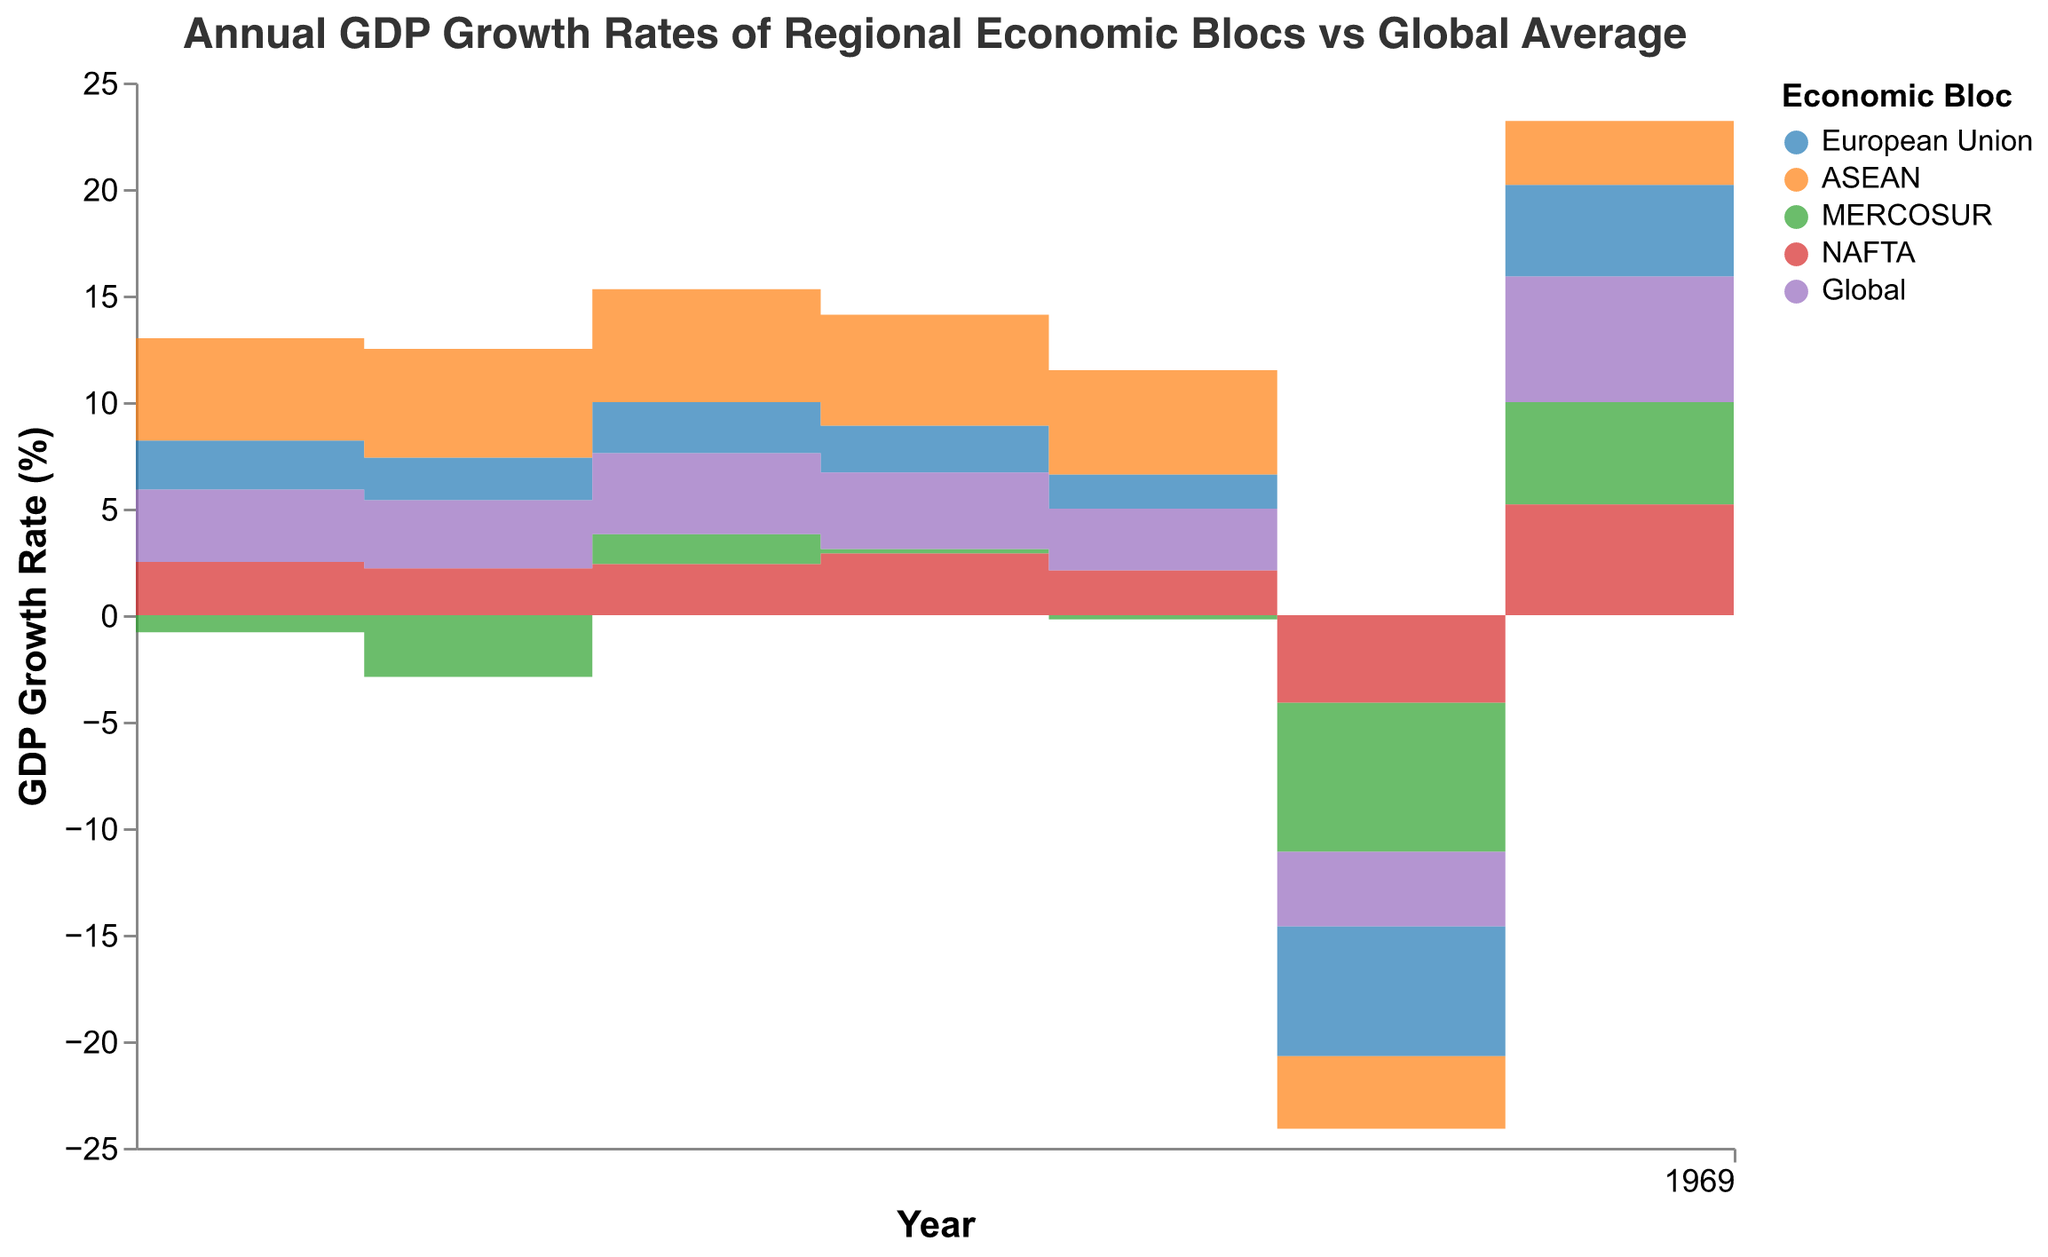What is the title of the chart? The chart title is prominently displayed at the top of the figure, indicating the main focus of the visualization. It reads "Annual GDP Growth Rates of Regional Economic Blocs vs Global Average."
Answer: Annual GDP Growth Rates of Regional Economic Blocs vs Global Average How did the GDP growth rate of the European Union change between 2019 and 2020? By observing the shape of the European Union area in the chart, we can see that the GDP growth rate significantly dropped from 1.6% in 2019 to -6.1% in 2020.
Answer: It dropped significantly Which economic bloc had the highest GDP growth rate in 2021? By comparing the heights of the areas for each economic bloc in the year 2021, it is evident that the Global bloc had a growth rate of 5.9%, which is higher than all the other economic blocs.
Answer: Global How does the GDP growth of ASEAN in 2017 compare to the Global average in the same year? ASEAN's GDP growth rate in 2017 is shown at around 5.3%, while the Global average for the same year is depicted as 3.8%. Comparing these values, ASEAN's growth rate is higher.
Answer: ASEAN's rate is higher What is the color representing MERCOSUR, and how did its GDP grow from 2016 to 2017? MERCOSUR is represented by the green color. In 2016, the GDP growth rate was -2.9%, and it increased to 1.4% in 2017, indicating a significant improvement.
Answer: Green, increased by 4.3% Which year saw the lowest GDP growth rate for NAFTA? By following the downward steps of the NAFTA area, we see that the lowest point is in the year 2020, where the GDP growth rate was -4.1%.
Answer: 2020 How many regions have a positive GDP growth rate in 2020? Observing the areas for each region in 2020, all of them, including the Global average, have negative GDP growth rates. Therefore, none have a positive growth rate.
Answer: None Was there any region matching the Global average GDP growth rate in any year? Assessing the chart for years where the region's step height matches that of the Global average, no region aligns exactly with the Global average across all observed years.
Answer: No When did ASEAN experience its highest GDP growth rate, and what was the rate? Looking at the step heights for ASEAN from 2015 to 2022, the highest point is in 2017 with a growth rate of 5.3%.
Answer: 2017, 5.3% Compare the changes in GDP growth rates from 2019 to 2020 for all regions. Which region experienced the most significant decline? From the chart, the decrease in GDP growth rates between 2019 to 2020 can be seen for all regions: EU dropped from 1.6% to -6.1%, ASEAN from 4.9% to -3.4%, MERCOSUR from -0.2% to -7.0%, NAFTA from 2.1% to -4.1%, and Global from 2.9% to -3.5%. The European Union experienced the most significant decline.
Answer: European Union 